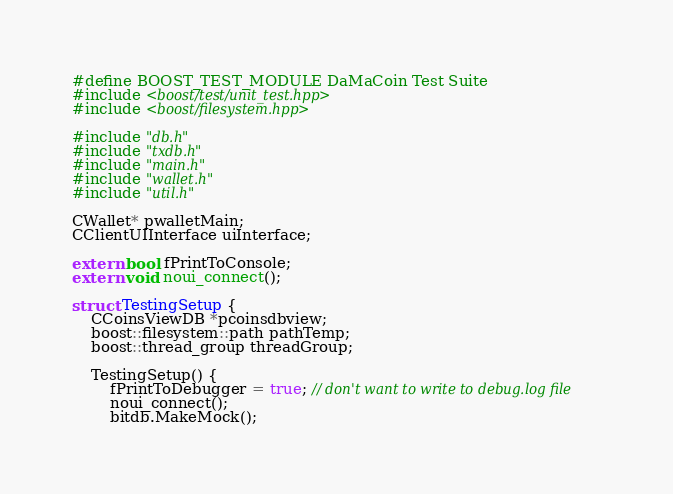<code> <loc_0><loc_0><loc_500><loc_500><_C++_>#define BOOST_TEST_MODULE DaMaCoin Test Suite
#include <boost/test/unit_test.hpp>
#include <boost/filesystem.hpp>

#include "db.h"
#include "txdb.h"
#include "main.h"
#include "wallet.h"
#include "util.h"

CWallet* pwalletMain;
CClientUIInterface uiInterface;

extern bool fPrintToConsole;
extern void noui_connect();

struct TestingSetup {
    CCoinsViewDB *pcoinsdbview;
    boost::filesystem::path pathTemp;
    boost::thread_group threadGroup;

    TestingSetup() {
        fPrintToDebugger = true; // don't want to write to debug.log file
        noui_connect();
        bitdb.MakeMock();</code> 